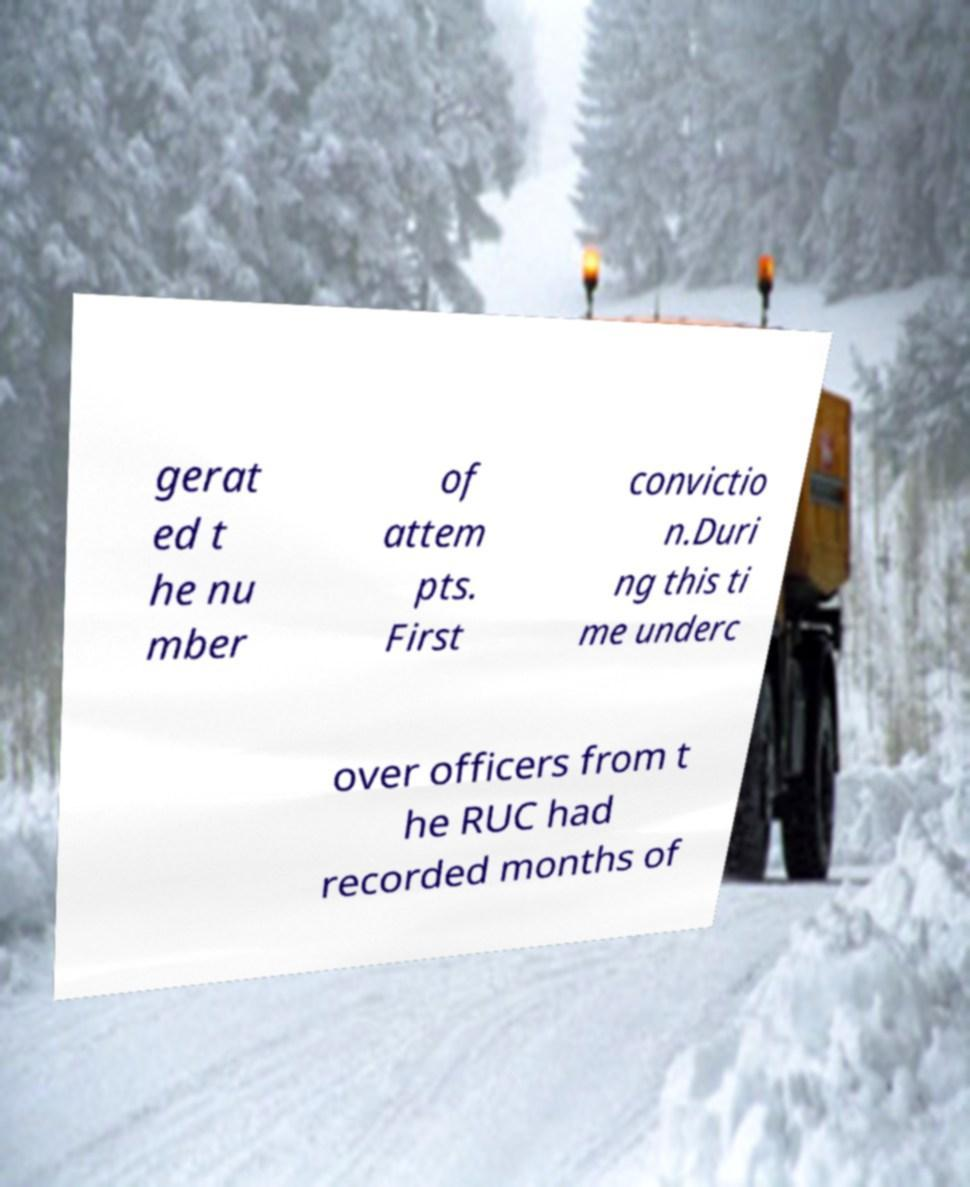What messages or text are displayed in this image? I need them in a readable, typed format. gerat ed t he nu mber of attem pts. First convictio n.Duri ng this ti me underc over officers from t he RUC had recorded months of 